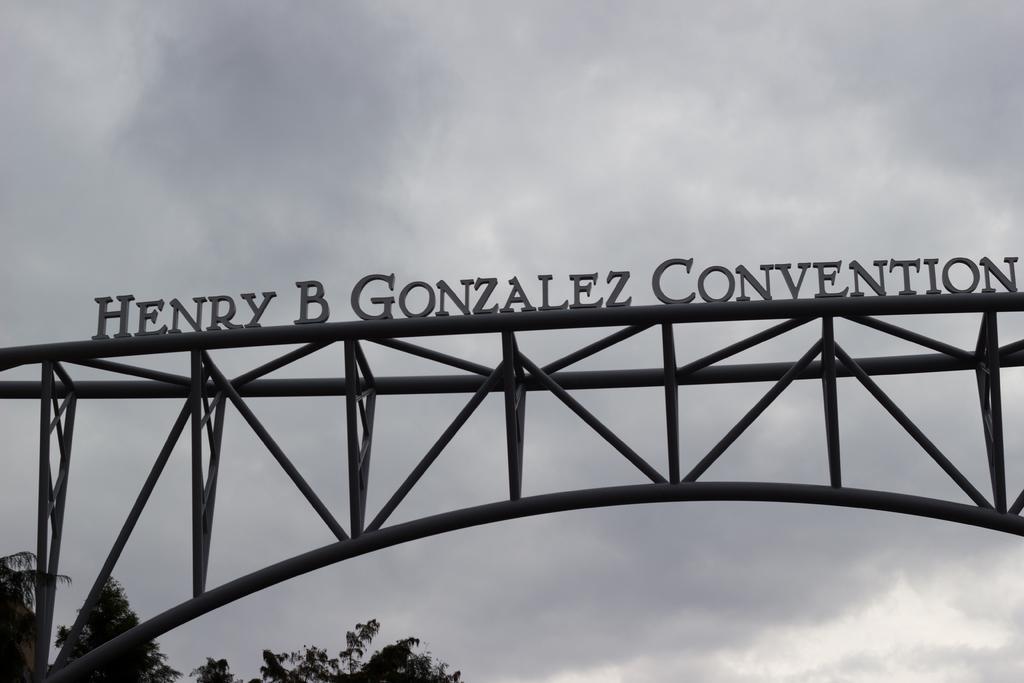Can you describe this image briefly? In this image I can see few iron poles and on the top of it I can see something is written. On the bottom side of this image I can see few trees and in the background I can see clouds and the sky. 